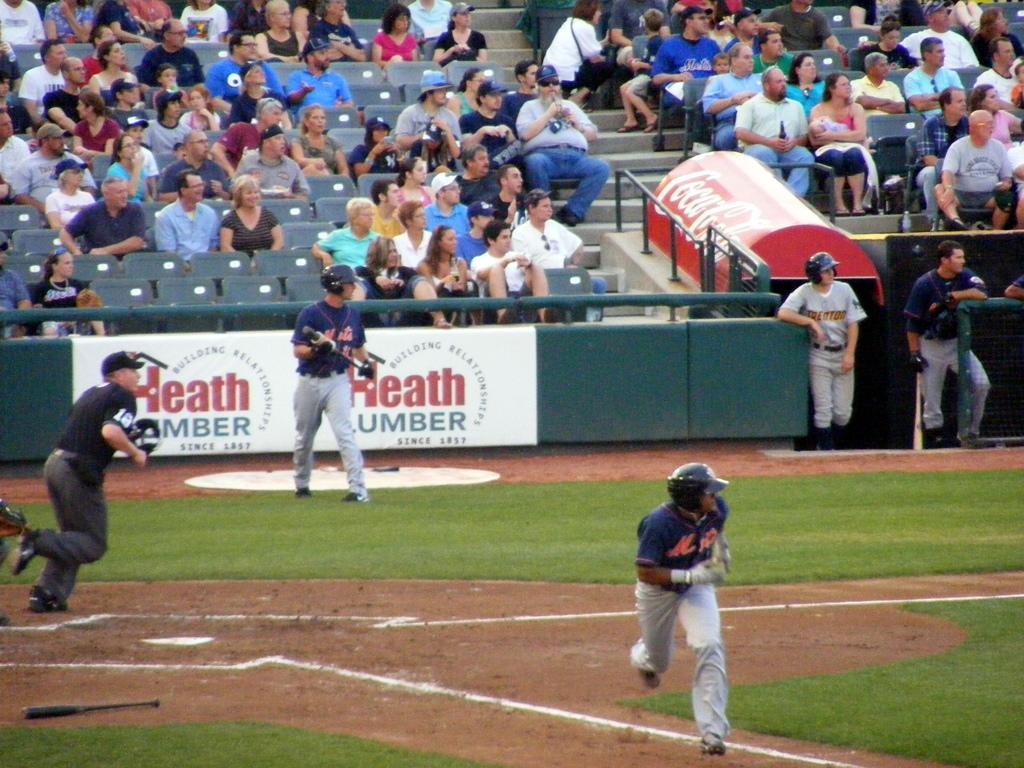<image>
Write a terse but informative summary of the picture. A baseball field sponsored by Heath Lumber and Coca-Cola. 